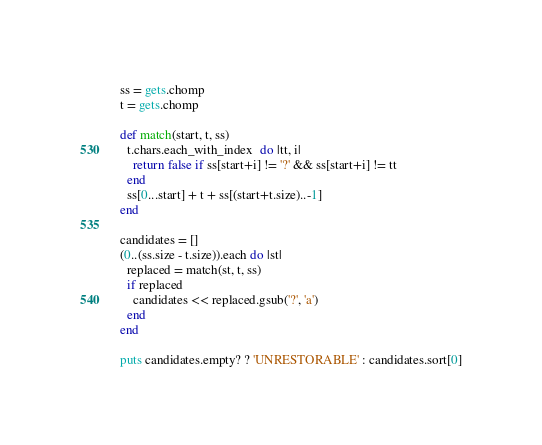<code> <loc_0><loc_0><loc_500><loc_500><_Ruby_>ss = gets.chomp
t = gets.chomp

def match(start, t, ss)
  t.chars.each_with_index  do |tt, i|
    return false if ss[start+i] != '?' && ss[start+i] != tt
  end
  ss[0...start] + t + ss[(start+t.size)..-1]
end

candidates = []
(0..(ss.size - t.size)).each do |st|
  replaced = match(st, t, ss)
  if replaced
    candidates << replaced.gsub('?', 'a')
  end
end

puts candidates.empty? ? 'UNRESTORABLE' : candidates.sort[0]</code> 